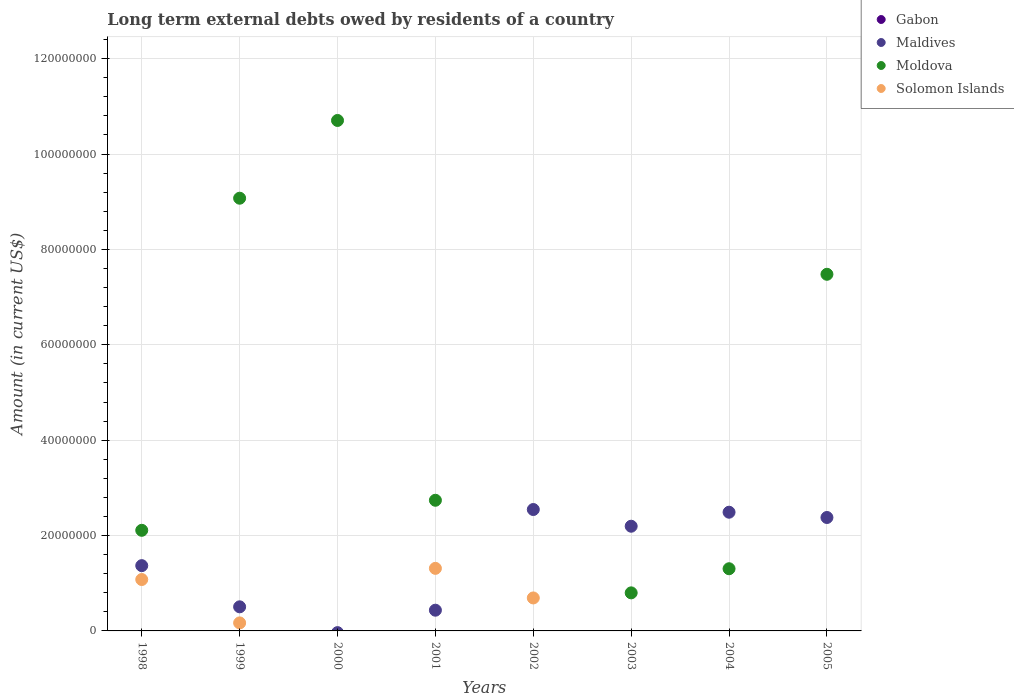How many different coloured dotlines are there?
Your response must be concise. 3. What is the amount of long-term external debts owed by residents in Moldova in 2001?
Ensure brevity in your answer.  2.74e+07. Across all years, what is the maximum amount of long-term external debts owed by residents in Maldives?
Make the answer very short. 2.55e+07. What is the total amount of long-term external debts owed by residents in Solomon Islands in the graph?
Make the answer very short. 3.25e+07. What is the difference between the amount of long-term external debts owed by residents in Maldives in 2003 and that in 2004?
Provide a succinct answer. -2.94e+06. What is the difference between the amount of long-term external debts owed by residents in Moldova in 1999 and the amount of long-term external debts owed by residents in Solomon Islands in 2005?
Your response must be concise. 9.07e+07. What is the average amount of long-term external debts owed by residents in Solomon Islands per year?
Provide a short and direct response. 4.06e+06. What is the ratio of the amount of long-term external debts owed by residents in Maldives in 2001 to that in 2004?
Give a very brief answer. 0.17. Is the amount of long-term external debts owed by residents in Moldova in 1998 less than that in 2005?
Give a very brief answer. Yes. What is the difference between the highest and the second highest amount of long-term external debts owed by residents in Maldives?
Provide a succinct answer. 5.66e+05. What is the difference between the highest and the lowest amount of long-term external debts owed by residents in Solomon Islands?
Offer a very short reply. 1.31e+07. In how many years, is the amount of long-term external debts owed by residents in Gabon greater than the average amount of long-term external debts owed by residents in Gabon taken over all years?
Provide a succinct answer. 0. Is the sum of the amount of long-term external debts owed by residents in Maldives in 2001 and 2002 greater than the maximum amount of long-term external debts owed by residents in Gabon across all years?
Provide a short and direct response. Yes. Is it the case that in every year, the sum of the amount of long-term external debts owed by residents in Maldives and amount of long-term external debts owed by residents in Moldova  is greater than the amount of long-term external debts owed by residents in Solomon Islands?
Your answer should be compact. Yes. Does the amount of long-term external debts owed by residents in Maldives monotonically increase over the years?
Your answer should be compact. No. How many dotlines are there?
Provide a short and direct response. 3. How many years are there in the graph?
Your response must be concise. 8. Are the values on the major ticks of Y-axis written in scientific E-notation?
Your response must be concise. No. Does the graph contain any zero values?
Provide a short and direct response. Yes. Where does the legend appear in the graph?
Provide a short and direct response. Top right. How are the legend labels stacked?
Provide a succinct answer. Vertical. What is the title of the graph?
Make the answer very short. Long term external debts owed by residents of a country. What is the label or title of the X-axis?
Keep it short and to the point. Years. What is the Amount (in current US$) of Gabon in 1998?
Give a very brief answer. 0. What is the Amount (in current US$) of Maldives in 1998?
Provide a short and direct response. 1.37e+07. What is the Amount (in current US$) of Moldova in 1998?
Keep it short and to the point. 2.11e+07. What is the Amount (in current US$) of Solomon Islands in 1998?
Your answer should be compact. 1.08e+07. What is the Amount (in current US$) of Maldives in 1999?
Your answer should be very brief. 5.05e+06. What is the Amount (in current US$) in Moldova in 1999?
Provide a succinct answer. 9.07e+07. What is the Amount (in current US$) of Solomon Islands in 1999?
Provide a succinct answer. 1.68e+06. What is the Amount (in current US$) in Maldives in 2000?
Offer a very short reply. 0. What is the Amount (in current US$) of Moldova in 2000?
Your answer should be very brief. 1.07e+08. What is the Amount (in current US$) in Solomon Islands in 2000?
Your answer should be compact. 0. What is the Amount (in current US$) of Maldives in 2001?
Give a very brief answer. 4.34e+06. What is the Amount (in current US$) of Moldova in 2001?
Give a very brief answer. 2.74e+07. What is the Amount (in current US$) in Solomon Islands in 2001?
Offer a terse response. 1.31e+07. What is the Amount (in current US$) in Gabon in 2002?
Provide a short and direct response. 0. What is the Amount (in current US$) of Maldives in 2002?
Offer a terse response. 2.55e+07. What is the Amount (in current US$) of Moldova in 2002?
Ensure brevity in your answer.  0. What is the Amount (in current US$) in Solomon Islands in 2002?
Give a very brief answer. 6.92e+06. What is the Amount (in current US$) of Gabon in 2003?
Your answer should be very brief. 0. What is the Amount (in current US$) of Maldives in 2003?
Make the answer very short. 2.20e+07. What is the Amount (in current US$) of Moldova in 2003?
Provide a short and direct response. 7.98e+06. What is the Amount (in current US$) of Maldives in 2004?
Provide a short and direct response. 2.49e+07. What is the Amount (in current US$) of Moldova in 2004?
Your response must be concise. 1.30e+07. What is the Amount (in current US$) of Gabon in 2005?
Your answer should be compact. 0. What is the Amount (in current US$) in Maldives in 2005?
Offer a very short reply. 2.38e+07. What is the Amount (in current US$) of Moldova in 2005?
Make the answer very short. 7.48e+07. Across all years, what is the maximum Amount (in current US$) of Maldives?
Make the answer very short. 2.55e+07. Across all years, what is the maximum Amount (in current US$) of Moldova?
Offer a terse response. 1.07e+08. Across all years, what is the maximum Amount (in current US$) of Solomon Islands?
Provide a succinct answer. 1.31e+07. Across all years, what is the minimum Amount (in current US$) of Solomon Islands?
Ensure brevity in your answer.  0. What is the total Amount (in current US$) in Maldives in the graph?
Your response must be concise. 1.19e+08. What is the total Amount (in current US$) in Moldova in the graph?
Offer a very short reply. 3.42e+08. What is the total Amount (in current US$) in Solomon Islands in the graph?
Provide a succinct answer. 3.25e+07. What is the difference between the Amount (in current US$) of Maldives in 1998 and that in 1999?
Provide a succinct answer. 8.64e+06. What is the difference between the Amount (in current US$) of Moldova in 1998 and that in 1999?
Make the answer very short. -6.96e+07. What is the difference between the Amount (in current US$) in Solomon Islands in 1998 and that in 1999?
Make the answer very short. 9.10e+06. What is the difference between the Amount (in current US$) in Moldova in 1998 and that in 2000?
Your answer should be very brief. -8.59e+07. What is the difference between the Amount (in current US$) in Maldives in 1998 and that in 2001?
Offer a terse response. 9.34e+06. What is the difference between the Amount (in current US$) in Moldova in 1998 and that in 2001?
Offer a very short reply. -6.30e+06. What is the difference between the Amount (in current US$) in Solomon Islands in 1998 and that in 2001?
Your answer should be compact. -2.34e+06. What is the difference between the Amount (in current US$) of Maldives in 1998 and that in 2002?
Provide a short and direct response. -1.18e+07. What is the difference between the Amount (in current US$) of Solomon Islands in 1998 and that in 2002?
Give a very brief answer. 3.86e+06. What is the difference between the Amount (in current US$) in Maldives in 1998 and that in 2003?
Provide a short and direct response. -8.26e+06. What is the difference between the Amount (in current US$) in Moldova in 1998 and that in 2003?
Offer a very short reply. 1.31e+07. What is the difference between the Amount (in current US$) in Maldives in 1998 and that in 2004?
Give a very brief answer. -1.12e+07. What is the difference between the Amount (in current US$) in Moldova in 1998 and that in 2004?
Keep it short and to the point. 8.06e+06. What is the difference between the Amount (in current US$) of Maldives in 1998 and that in 2005?
Your response must be concise. -1.01e+07. What is the difference between the Amount (in current US$) in Moldova in 1998 and that in 2005?
Ensure brevity in your answer.  -5.37e+07. What is the difference between the Amount (in current US$) in Moldova in 1999 and that in 2000?
Give a very brief answer. -1.63e+07. What is the difference between the Amount (in current US$) in Maldives in 1999 and that in 2001?
Provide a succinct answer. 7.08e+05. What is the difference between the Amount (in current US$) in Moldova in 1999 and that in 2001?
Provide a succinct answer. 6.33e+07. What is the difference between the Amount (in current US$) of Solomon Islands in 1999 and that in 2001?
Your answer should be very brief. -1.14e+07. What is the difference between the Amount (in current US$) of Maldives in 1999 and that in 2002?
Keep it short and to the point. -2.04e+07. What is the difference between the Amount (in current US$) of Solomon Islands in 1999 and that in 2002?
Make the answer very short. -5.23e+06. What is the difference between the Amount (in current US$) in Maldives in 1999 and that in 2003?
Your response must be concise. -1.69e+07. What is the difference between the Amount (in current US$) of Moldova in 1999 and that in 2003?
Provide a short and direct response. 8.28e+07. What is the difference between the Amount (in current US$) of Maldives in 1999 and that in 2004?
Give a very brief answer. -1.98e+07. What is the difference between the Amount (in current US$) of Moldova in 1999 and that in 2004?
Give a very brief answer. 7.77e+07. What is the difference between the Amount (in current US$) in Maldives in 1999 and that in 2005?
Make the answer very short. -1.87e+07. What is the difference between the Amount (in current US$) in Moldova in 1999 and that in 2005?
Your response must be concise. 1.60e+07. What is the difference between the Amount (in current US$) of Moldova in 2000 and that in 2001?
Give a very brief answer. 7.96e+07. What is the difference between the Amount (in current US$) of Moldova in 2000 and that in 2003?
Your answer should be compact. 9.91e+07. What is the difference between the Amount (in current US$) in Moldova in 2000 and that in 2004?
Provide a short and direct response. 9.40e+07. What is the difference between the Amount (in current US$) in Moldova in 2000 and that in 2005?
Your response must be concise. 3.23e+07. What is the difference between the Amount (in current US$) of Maldives in 2001 and that in 2002?
Give a very brief answer. -2.11e+07. What is the difference between the Amount (in current US$) in Solomon Islands in 2001 and that in 2002?
Offer a terse response. 6.20e+06. What is the difference between the Amount (in current US$) in Maldives in 2001 and that in 2003?
Provide a succinct answer. -1.76e+07. What is the difference between the Amount (in current US$) of Moldova in 2001 and that in 2003?
Offer a very short reply. 1.94e+07. What is the difference between the Amount (in current US$) in Maldives in 2001 and that in 2004?
Your answer should be compact. -2.05e+07. What is the difference between the Amount (in current US$) of Moldova in 2001 and that in 2004?
Your answer should be very brief. 1.44e+07. What is the difference between the Amount (in current US$) of Maldives in 2001 and that in 2005?
Give a very brief answer. -1.94e+07. What is the difference between the Amount (in current US$) in Moldova in 2001 and that in 2005?
Your response must be concise. -4.74e+07. What is the difference between the Amount (in current US$) in Maldives in 2002 and that in 2003?
Your response must be concise. 3.50e+06. What is the difference between the Amount (in current US$) of Maldives in 2002 and that in 2004?
Provide a succinct answer. 5.66e+05. What is the difference between the Amount (in current US$) of Maldives in 2002 and that in 2005?
Provide a succinct answer. 1.67e+06. What is the difference between the Amount (in current US$) in Maldives in 2003 and that in 2004?
Your answer should be compact. -2.94e+06. What is the difference between the Amount (in current US$) in Moldova in 2003 and that in 2004?
Your response must be concise. -5.06e+06. What is the difference between the Amount (in current US$) of Maldives in 2003 and that in 2005?
Offer a very short reply. -1.83e+06. What is the difference between the Amount (in current US$) of Moldova in 2003 and that in 2005?
Provide a short and direct response. -6.68e+07. What is the difference between the Amount (in current US$) in Maldives in 2004 and that in 2005?
Offer a terse response. 1.11e+06. What is the difference between the Amount (in current US$) in Moldova in 2004 and that in 2005?
Make the answer very short. -6.17e+07. What is the difference between the Amount (in current US$) of Maldives in 1998 and the Amount (in current US$) of Moldova in 1999?
Offer a very short reply. -7.71e+07. What is the difference between the Amount (in current US$) of Maldives in 1998 and the Amount (in current US$) of Solomon Islands in 1999?
Your response must be concise. 1.20e+07. What is the difference between the Amount (in current US$) of Moldova in 1998 and the Amount (in current US$) of Solomon Islands in 1999?
Your answer should be compact. 1.94e+07. What is the difference between the Amount (in current US$) in Maldives in 1998 and the Amount (in current US$) in Moldova in 2000?
Keep it short and to the point. -9.34e+07. What is the difference between the Amount (in current US$) in Maldives in 1998 and the Amount (in current US$) in Moldova in 2001?
Your answer should be compact. -1.37e+07. What is the difference between the Amount (in current US$) of Maldives in 1998 and the Amount (in current US$) of Solomon Islands in 2001?
Your answer should be compact. 5.68e+05. What is the difference between the Amount (in current US$) in Moldova in 1998 and the Amount (in current US$) in Solomon Islands in 2001?
Your answer should be compact. 7.98e+06. What is the difference between the Amount (in current US$) in Maldives in 1998 and the Amount (in current US$) in Solomon Islands in 2002?
Keep it short and to the point. 6.77e+06. What is the difference between the Amount (in current US$) of Moldova in 1998 and the Amount (in current US$) of Solomon Islands in 2002?
Offer a terse response. 1.42e+07. What is the difference between the Amount (in current US$) in Maldives in 1998 and the Amount (in current US$) in Moldova in 2003?
Offer a terse response. 5.71e+06. What is the difference between the Amount (in current US$) of Maldives in 1998 and the Amount (in current US$) of Moldova in 2004?
Your response must be concise. 6.48e+05. What is the difference between the Amount (in current US$) of Maldives in 1998 and the Amount (in current US$) of Moldova in 2005?
Your response must be concise. -6.11e+07. What is the difference between the Amount (in current US$) in Maldives in 1999 and the Amount (in current US$) in Moldova in 2000?
Keep it short and to the point. -1.02e+08. What is the difference between the Amount (in current US$) of Maldives in 1999 and the Amount (in current US$) of Moldova in 2001?
Your answer should be compact. -2.23e+07. What is the difference between the Amount (in current US$) of Maldives in 1999 and the Amount (in current US$) of Solomon Islands in 2001?
Keep it short and to the point. -8.07e+06. What is the difference between the Amount (in current US$) in Moldova in 1999 and the Amount (in current US$) in Solomon Islands in 2001?
Provide a short and direct response. 7.76e+07. What is the difference between the Amount (in current US$) of Maldives in 1999 and the Amount (in current US$) of Solomon Islands in 2002?
Your answer should be compact. -1.86e+06. What is the difference between the Amount (in current US$) of Moldova in 1999 and the Amount (in current US$) of Solomon Islands in 2002?
Your answer should be very brief. 8.38e+07. What is the difference between the Amount (in current US$) in Maldives in 1999 and the Amount (in current US$) in Moldova in 2003?
Provide a short and direct response. -2.93e+06. What is the difference between the Amount (in current US$) in Maldives in 1999 and the Amount (in current US$) in Moldova in 2004?
Make the answer very short. -7.99e+06. What is the difference between the Amount (in current US$) in Maldives in 1999 and the Amount (in current US$) in Moldova in 2005?
Your answer should be very brief. -6.97e+07. What is the difference between the Amount (in current US$) in Moldova in 2000 and the Amount (in current US$) in Solomon Islands in 2001?
Offer a terse response. 9.39e+07. What is the difference between the Amount (in current US$) in Moldova in 2000 and the Amount (in current US$) in Solomon Islands in 2002?
Offer a terse response. 1.00e+08. What is the difference between the Amount (in current US$) of Maldives in 2001 and the Amount (in current US$) of Solomon Islands in 2002?
Your answer should be compact. -2.57e+06. What is the difference between the Amount (in current US$) in Moldova in 2001 and the Amount (in current US$) in Solomon Islands in 2002?
Your response must be concise. 2.05e+07. What is the difference between the Amount (in current US$) of Maldives in 2001 and the Amount (in current US$) of Moldova in 2003?
Provide a succinct answer. -3.64e+06. What is the difference between the Amount (in current US$) of Maldives in 2001 and the Amount (in current US$) of Moldova in 2004?
Ensure brevity in your answer.  -8.70e+06. What is the difference between the Amount (in current US$) in Maldives in 2001 and the Amount (in current US$) in Moldova in 2005?
Give a very brief answer. -7.04e+07. What is the difference between the Amount (in current US$) in Maldives in 2002 and the Amount (in current US$) in Moldova in 2003?
Provide a succinct answer. 1.75e+07. What is the difference between the Amount (in current US$) of Maldives in 2002 and the Amount (in current US$) of Moldova in 2004?
Your answer should be compact. 1.24e+07. What is the difference between the Amount (in current US$) in Maldives in 2002 and the Amount (in current US$) in Moldova in 2005?
Offer a very short reply. -4.93e+07. What is the difference between the Amount (in current US$) of Maldives in 2003 and the Amount (in current US$) of Moldova in 2004?
Provide a short and direct response. 8.91e+06. What is the difference between the Amount (in current US$) of Maldives in 2003 and the Amount (in current US$) of Moldova in 2005?
Keep it short and to the point. -5.28e+07. What is the difference between the Amount (in current US$) in Maldives in 2004 and the Amount (in current US$) in Moldova in 2005?
Make the answer very short. -4.99e+07. What is the average Amount (in current US$) of Maldives per year?
Provide a short and direct response. 1.49e+07. What is the average Amount (in current US$) of Moldova per year?
Offer a very short reply. 4.28e+07. What is the average Amount (in current US$) in Solomon Islands per year?
Provide a succinct answer. 4.06e+06. In the year 1998, what is the difference between the Amount (in current US$) of Maldives and Amount (in current US$) of Moldova?
Ensure brevity in your answer.  -7.41e+06. In the year 1998, what is the difference between the Amount (in current US$) in Maldives and Amount (in current US$) in Solomon Islands?
Provide a short and direct response. 2.91e+06. In the year 1998, what is the difference between the Amount (in current US$) of Moldova and Amount (in current US$) of Solomon Islands?
Make the answer very short. 1.03e+07. In the year 1999, what is the difference between the Amount (in current US$) of Maldives and Amount (in current US$) of Moldova?
Give a very brief answer. -8.57e+07. In the year 1999, what is the difference between the Amount (in current US$) of Maldives and Amount (in current US$) of Solomon Islands?
Ensure brevity in your answer.  3.37e+06. In the year 1999, what is the difference between the Amount (in current US$) in Moldova and Amount (in current US$) in Solomon Islands?
Provide a succinct answer. 8.91e+07. In the year 2001, what is the difference between the Amount (in current US$) in Maldives and Amount (in current US$) in Moldova?
Make the answer very short. -2.31e+07. In the year 2001, what is the difference between the Amount (in current US$) in Maldives and Amount (in current US$) in Solomon Islands?
Your answer should be very brief. -8.78e+06. In the year 2001, what is the difference between the Amount (in current US$) of Moldova and Amount (in current US$) of Solomon Islands?
Your answer should be very brief. 1.43e+07. In the year 2002, what is the difference between the Amount (in current US$) of Maldives and Amount (in current US$) of Solomon Islands?
Ensure brevity in your answer.  1.85e+07. In the year 2003, what is the difference between the Amount (in current US$) of Maldives and Amount (in current US$) of Moldova?
Provide a succinct answer. 1.40e+07. In the year 2004, what is the difference between the Amount (in current US$) of Maldives and Amount (in current US$) of Moldova?
Offer a terse response. 1.19e+07. In the year 2005, what is the difference between the Amount (in current US$) of Maldives and Amount (in current US$) of Moldova?
Make the answer very short. -5.10e+07. What is the ratio of the Amount (in current US$) in Maldives in 1998 to that in 1999?
Provide a short and direct response. 2.71. What is the ratio of the Amount (in current US$) in Moldova in 1998 to that in 1999?
Offer a terse response. 0.23. What is the ratio of the Amount (in current US$) of Solomon Islands in 1998 to that in 1999?
Ensure brevity in your answer.  6.41. What is the ratio of the Amount (in current US$) in Moldova in 1998 to that in 2000?
Ensure brevity in your answer.  0.2. What is the ratio of the Amount (in current US$) of Maldives in 1998 to that in 2001?
Your answer should be compact. 3.15. What is the ratio of the Amount (in current US$) in Moldova in 1998 to that in 2001?
Ensure brevity in your answer.  0.77. What is the ratio of the Amount (in current US$) in Solomon Islands in 1998 to that in 2001?
Give a very brief answer. 0.82. What is the ratio of the Amount (in current US$) of Maldives in 1998 to that in 2002?
Ensure brevity in your answer.  0.54. What is the ratio of the Amount (in current US$) of Solomon Islands in 1998 to that in 2002?
Offer a very short reply. 1.56. What is the ratio of the Amount (in current US$) in Maldives in 1998 to that in 2003?
Your answer should be compact. 0.62. What is the ratio of the Amount (in current US$) in Moldova in 1998 to that in 2003?
Provide a short and direct response. 2.64. What is the ratio of the Amount (in current US$) in Maldives in 1998 to that in 2004?
Offer a very short reply. 0.55. What is the ratio of the Amount (in current US$) in Moldova in 1998 to that in 2004?
Make the answer very short. 1.62. What is the ratio of the Amount (in current US$) in Maldives in 1998 to that in 2005?
Make the answer very short. 0.58. What is the ratio of the Amount (in current US$) in Moldova in 1998 to that in 2005?
Give a very brief answer. 0.28. What is the ratio of the Amount (in current US$) of Moldova in 1999 to that in 2000?
Ensure brevity in your answer.  0.85. What is the ratio of the Amount (in current US$) in Maldives in 1999 to that in 2001?
Provide a succinct answer. 1.16. What is the ratio of the Amount (in current US$) of Moldova in 1999 to that in 2001?
Give a very brief answer. 3.31. What is the ratio of the Amount (in current US$) in Solomon Islands in 1999 to that in 2001?
Provide a short and direct response. 0.13. What is the ratio of the Amount (in current US$) in Maldives in 1999 to that in 2002?
Keep it short and to the point. 0.2. What is the ratio of the Amount (in current US$) of Solomon Islands in 1999 to that in 2002?
Make the answer very short. 0.24. What is the ratio of the Amount (in current US$) of Maldives in 1999 to that in 2003?
Offer a very short reply. 0.23. What is the ratio of the Amount (in current US$) in Moldova in 1999 to that in 2003?
Your answer should be compact. 11.37. What is the ratio of the Amount (in current US$) in Maldives in 1999 to that in 2004?
Your answer should be compact. 0.2. What is the ratio of the Amount (in current US$) of Moldova in 1999 to that in 2004?
Offer a very short reply. 6.96. What is the ratio of the Amount (in current US$) in Maldives in 1999 to that in 2005?
Your response must be concise. 0.21. What is the ratio of the Amount (in current US$) in Moldova in 1999 to that in 2005?
Your answer should be very brief. 1.21. What is the ratio of the Amount (in current US$) of Moldova in 2000 to that in 2001?
Provide a succinct answer. 3.91. What is the ratio of the Amount (in current US$) in Moldova in 2000 to that in 2003?
Ensure brevity in your answer.  13.41. What is the ratio of the Amount (in current US$) in Moldova in 2000 to that in 2004?
Offer a terse response. 8.21. What is the ratio of the Amount (in current US$) of Moldova in 2000 to that in 2005?
Offer a terse response. 1.43. What is the ratio of the Amount (in current US$) of Maldives in 2001 to that in 2002?
Give a very brief answer. 0.17. What is the ratio of the Amount (in current US$) in Solomon Islands in 2001 to that in 2002?
Your answer should be compact. 1.9. What is the ratio of the Amount (in current US$) in Maldives in 2001 to that in 2003?
Keep it short and to the point. 0.2. What is the ratio of the Amount (in current US$) in Moldova in 2001 to that in 2003?
Keep it short and to the point. 3.43. What is the ratio of the Amount (in current US$) of Maldives in 2001 to that in 2004?
Your response must be concise. 0.17. What is the ratio of the Amount (in current US$) of Moldova in 2001 to that in 2004?
Provide a short and direct response. 2.1. What is the ratio of the Amount (in current US$) of Maldives in 2001 to that in 2005?
Make the answer very short. 0.18. What is the ratio of the Amount (in current US$) of Moldova in 2001 to that in 2005?
Ensure brevity in your answer.  0.37. What is the ratio of the Amount (in current US$) in Maldives in 2002 to that in 2003?
Provide a succinct answer. 1.16. What is the ratio of the Amount (in current US$) in Maldives in 2002 to that in 2004?
Provide a succinct answer. 1.02. What is the ratio of the Amount (in current US$) of Maldives in 2002 to that in 2005?
Provide a succinct answer. 1.07. What is the ratio of the Amount (in current US$) of Maldives in 2003 to that in 2004?
Keep it short and to the point. 0.88. What is the ratio of the Amount (in current US$) in Moldova in 2003 to that in 2004?
Provide a succinct answer. 0.61. What is the ratio of the Amount (in current US$) in Maldives in 2003 to that in 2005?
Ensure brevity in your answer.  0.92. What is the ratio of the Amount (in current US$) in Moldova in 2003 to that in 2005?
Offer a terse response. 0.11. What is the ratio of the Amount (in current US$) of Maldives in 2004 to that in 2005?
Give a very brief answer. 1.05. What is the ratio of the Amount (in current US$) in Moldova in 2004 to that in 2005?
Offer a terse response. 0.17. What is the difference between the highest and the second highest Amount (in current US$) in Maldives?
Provide a succinct answer. 5.66e+05. What is the difference between the highest and the second highest Amount (in current US$) in Moldova?
Provide a succinct answer. 1.63e+07. What is the difference between the highest and the second highest Amount (in current US$) of Solomon Islands?
Keep it short and to the point. 2.34e+06. What is the difference between the highest and the lowest Amount (in current US$) in Maldives?
Provide a succinct answer. 2.55e+07. What is the difference between the highest and the lowest Amount (in current US$) of Moldova?
Ensure brevity in your answer.  1.07e+08. What is the difference between the highest and the lowest Amount (in current US$) in Solomon Islands?
Offer a terse response. 1.31e+07. 